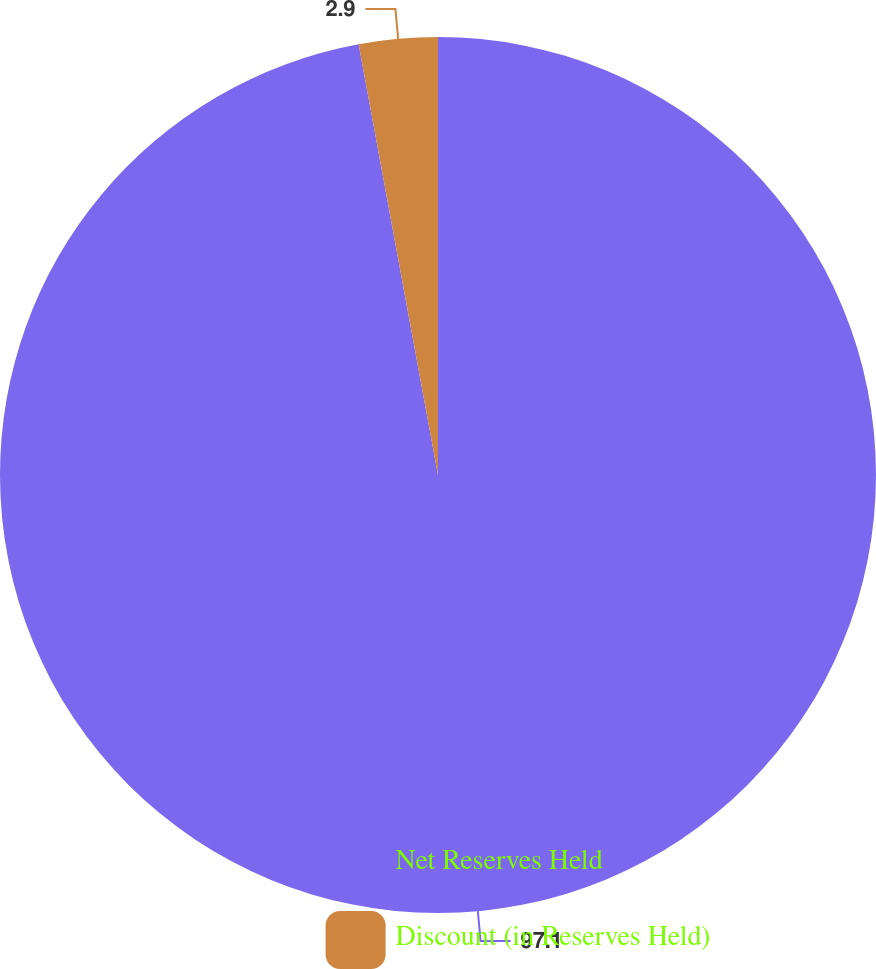<chart> <loc_0><loc_0><loc_500><loc_500><pie_chart><fcel>Net Reserves Held<fcel>Discount (in Reserves Held)<nl><fcel>97.1%<fcel>2.9%<nl></chart> 